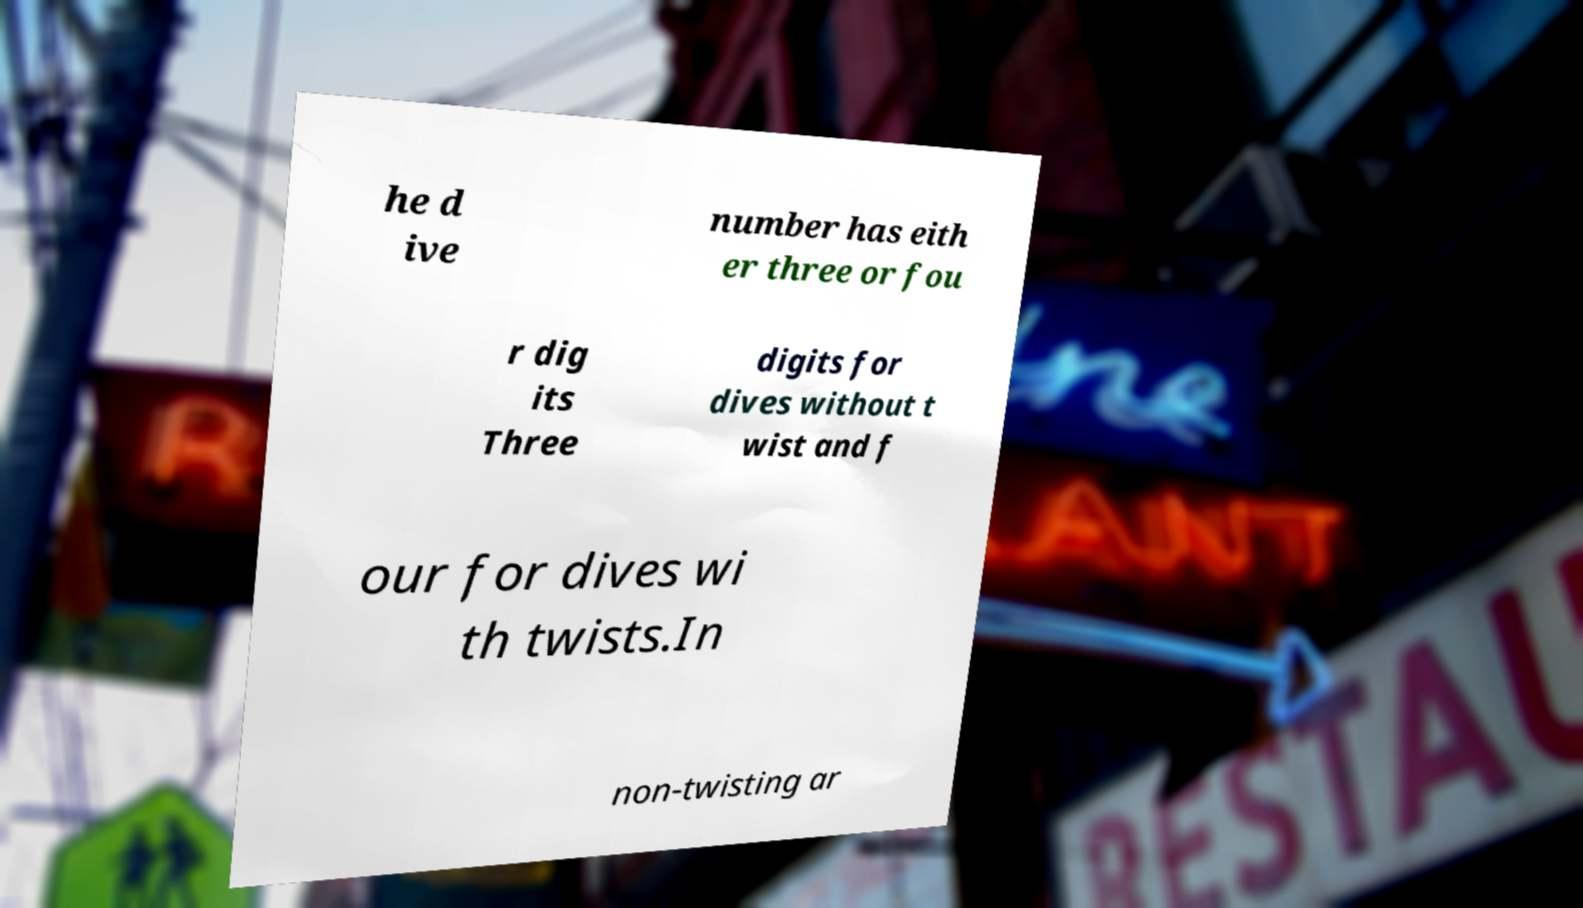Please identify and transcribe the text found in this image. he d ive number has eith er three or fou r dig its Three digits for dives without t wist and f our for dives wi th twists.In non-twisting ar 